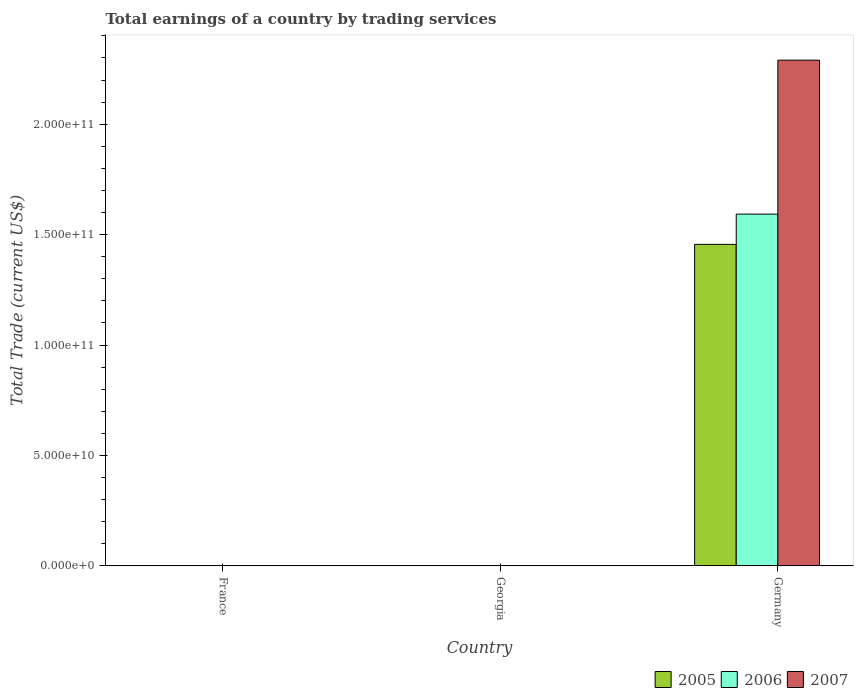Are the number of bars per tick equal to the number of legend labels?
Provide a short and direct response. No. How many bars are there on the 3rd tick from the right?
Give a very brief answer. 0. In how many cases, is the number of bars for a given country not equal to the number of legend labels?
Offer a terse response. 2. Across all countries, what is the maximum total earnings in 2005?
Give a very brief answer. 1.46e+11. Across all countries, what is the minimum total earnings in 2007?
Provide a short and direct response. 0. What is the total total earnings in 2006 in the graph?
Your answer should be compact. 1.59e+11. What is the average total earnings in 2005 per country?
Offer a terse response. 4.85e+1. What is the difference between the total earnings of/in 2007 and total earnings of/in 2005 in Germany?
Provide a succinct answer. 8.34e+1. What is the difference between the highest and the lowest total earnings in 2007?
Provide a succinct answer. 2.29e+11. Is it the case that in every country, the sum of the total earnings in 2005 and total earnings in 2006 is greater than the total earnings in 2007?
Your response must be concise. No. How many bars are there?
Your answer should be compact. 3. How many countries are there in the graph?
Ensure brevity in your answer.  3. What is the difference between two consecutive major ticks on the Y-axis?
Provide a short and direct response. 5.00e+1. Are the values on the major ticks of Y-axis written in scientific E-notation?
Provide a succinct answer. Yes. Does the graph contain any zero values?
Keep it short and to the point. Yes. Does the graph contain grids?
Keep it short and to the point. No. How many legend labels are there?
Provide a succinct answer. 3. How are the legend labels stacked?
Offer a terse response. Horizontal. What is the title of the graph?
Provide a succinct answer. Total earnings of a country by trading services. Does "1999" appear as one of the legend labels in the graph?
Make the answer very short. No. What is the label or title of the X-axis?
Offer a terse response. Country. What is the label or title of the Y-axis?
Provide a succinct answer. Total Trade (current US$). What is the Total Trade (current US$) in 2005 in France?
Make the answer very short. 0. What is the Total Trade (current US$) in 2007 in France?
Offer a terse response. 0. What is the Total Trade (current US$) of 2005 in Georgia?
Keep it short and to the point. 0. What is the Total Trade (current US$) in 2006 in Georgia?
Give a very brief answer. 0. What is the Total Trade (current US$) in 2005 in Germany?
Provide a succinct answer. 1.46e+11. What is the Total Trade (current US$) of 2006 in Germany?
Give a very brief answer. 1.59e+11. What is the Total Trade (current US$) of 2007 in Germany?
Offer a very short reply. 2.29e+11. Across all countries, what is the maximum Total Trade (current US$) in 2005?
Offer a very short reply. 1.46e+11. Across all countries, what is the maximum Total Trade (current US$) of 2006?
Provide a short and direct response. 1.59e+11. Across all countries, what is the maximum Total Trade (current US$) of 2007?
Provide a short and direct response. 2.29e+11. Across all countries, what is the minimum Total Trade (current US$) of 2005?
Keep it short and to the point. 0. Across all countries, what is the minimum Total Trade (current US$) in 2006?
Provide a short and direct response. 0. Across all countries, what is the minimum Total Trade (current US$) in 2007?
Your response must be concise. 0. What is the total Total Trade (current US$) in 2005 in the graph?
Make the answer very short. 1.46e+11. What is the total Total Trade (current US$) in 2006 in the graph?
Your response must be concise. 1.59e+11. What is the total Total Trade (current US$) in 2007 in the graph?
Offer a terse response. 2.29e+11. What is the average Total Trade (current US$) in 2005 per country?
Offer a very short reply. 4.85e+1. What is the average Total Trade (current US$) of 2006 per country?
Provide a short and direct response. 5.31e+1. What is the average Total Trade (current US$) in 2007 per country?
Offer a very short reply. 7.63e+1. What is the difference between the Total Trade (current US$) of 2005 and Total Trade (current US$) of 2006 in Germany?
Provide a short and direct response. -1.37e+1. What is the difference between the Total Trade (current US$) of 2005 and Total Trade (current US$) of 2007 in Germany?
Offer a very short reply. -8.34e+1. What is the difference between the Total Trade (current US$) of 2006 and Total Trade (current US$) of 2007 in Germany?
Your answer should be compact. -6.97e+1. What is the difference between the highest and the lowest Total Trade (current US$) in 2005?
Give a very brief answer. 1.46e+11. What is the difference between the highest and the lowest Total Trade (current US$) of 2006?
Make the answer very short. 1.59e+11. What is the difference between the highest and the lowest Total Trade (current US$) in 2007?
Offer a very short reply. 2.29e+11. 